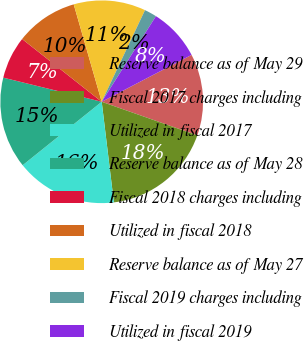Convert chart. <chart><loc_0><loc_0><loc_500><loc_500><pie_chart><fcel>Reserve balance as of May 29<fcel>Fiscal 2017 charges including<fcel>Utilized in fiscal 2017<fcel>Reserve balance as of May 28<fcel>Fiscal 2018 charges including<fcel>Utilized in fiscal 2018<fcel>Reserve balance as of May 27<fcel>Fiscal 2019 charges including<fcel>Utilized in fiscal 2019<nl><fcel>13.03%<fcel>17.71%<fcel>16.15%<fcel>14.59%<fcel>6.8%<fcel>9.92%<fcel>11.48%<fcel>1.96%<fcel>8.36%<nl></chart> 